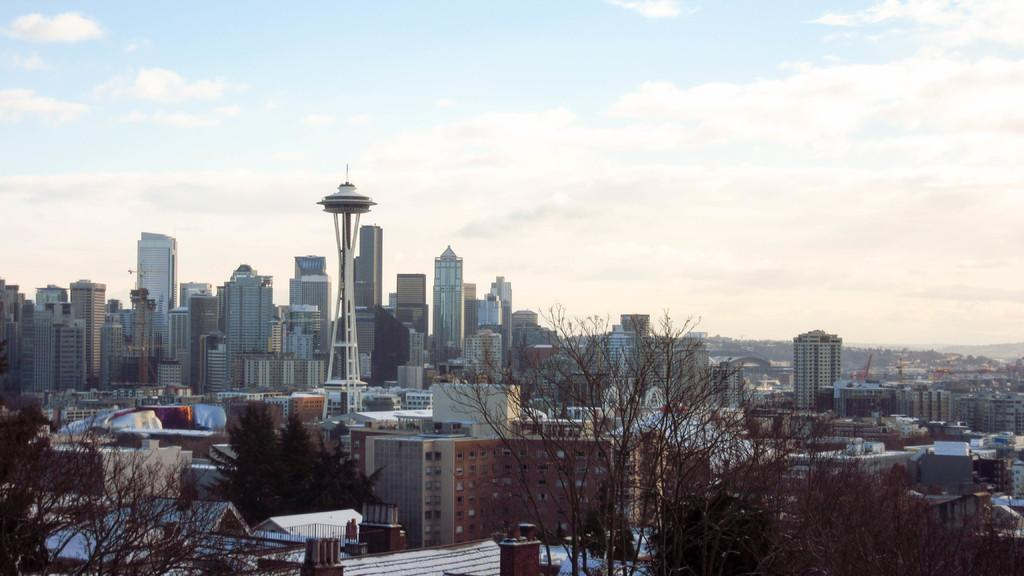What type of location is shown in the image? The image depicts a city. What structures can be seen in the city? There are buildings, a tower, and cranes in the image. Are there any natural elements present in the city? Yes, there are trees in the image. What is visible at the top of the image? The sky is visible at the top of the image, and there are clouds in the sky. Where is the zoo located in the image? There is no zoo present in the image; it depicts a city with buildings, trees, and cranes. How many times is the tank kicked in the image? There is no tank or kicking activity present in the image. 